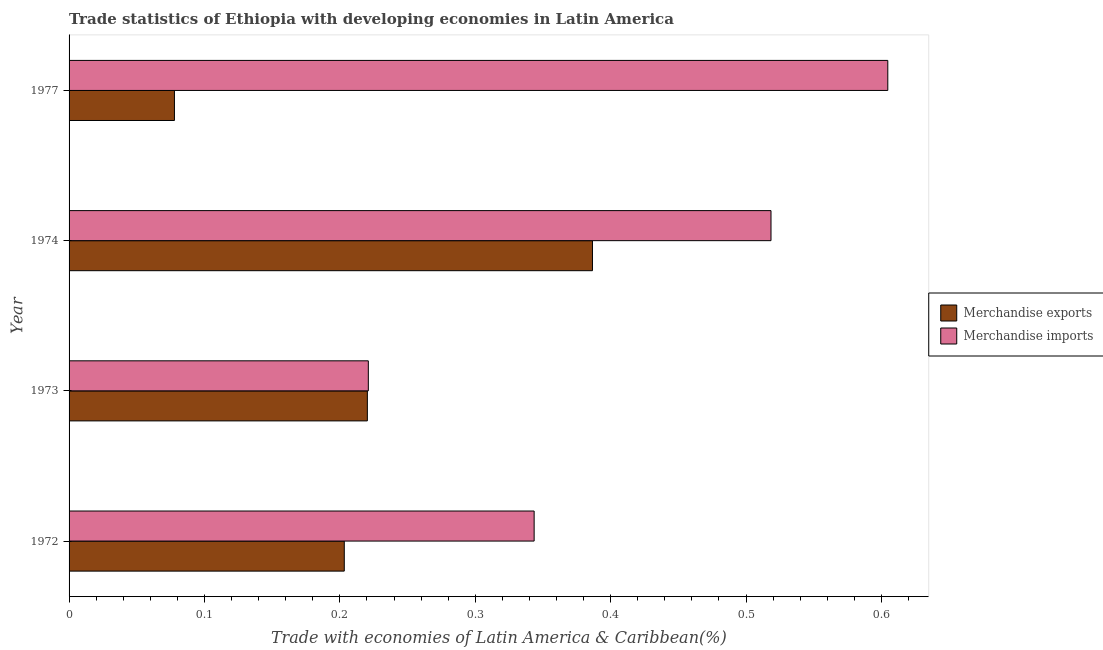Are the number of bars per tick equal to the number of legend labels?
Provide a short and direct response. Yes. Are the number of bars on each tick of the Y-axis equal?
Make the answer very short. Yes. How many bars are there on the 2nd tick from the bottom?
Ensure brevity in your answer.  2. What is the label of the 2nd group of bars from the top?
Give a very brief answer. 1974. What is the merchandise exports in 1973?
Make the answer very short. 0.22. Across all years, what is the maximum merchandise exports?
Provide a succinct answer. 0.39. Across all years, what is the minimum merchandise exports?
Provide a short and direct response. 0.08. In which year was the merchandise exports maximum?
Your answer should be very brief. 1974. In which year was the merchandise exports minimum?
Your answer should be very brief. 1977. What is the total merchandise imports in the graph?
Your answer should be compact. 1.69. What is the difference between the merchandise exports in 1974 and that in 1977?
Give a very brief answer. 0.31. What is the difference between the merchandise exports in 1977 and the merchandise imports in 1972?
Ensure brevity in your answer.  -0.27. What is the average merchandise exports per year?
Make the answer very short. 0.22. In the year 1974, what is the difference between the merchandise imports and merchandise exports?
Keep it short and to the point. 0.13. What is the ratio of the merchandise imports in 1972 to that in 1977?
Give a very brief answer. 0.57. Is the difference between the merchandise imports in 1973 and 1977 greater than the difference between the merchandise exports in 1973 and 1977?
Your answer should be very brief. No. What is the difference between the highest and the second highest merchandise exports?
Offer a very short reply. 0.17. What is the difference between the highest and the lowest merchandise imports?
Give a very brief answer. 0.38. In how many years, is the merchandise exports greater than the average merchandise exports taken over all years?
Your answer should be very brief. 1. How many years are there in the graph?
Ensure brevity in your answer.  4. What is the difference between two consecutive major ticks on the X-axis?
Offer a terse response. 0.1. How are the legend labels stacked?
Keep it short and to the point. Vertical. What is the title of the graph?
Provide a short and direct response. Trade statistics of Ethiopia with developing economies in Latin America. Does "Methane" appear as one of the legend labels in the graph?
Your answer should be compact. No. What is the label or title of the X-axis?
Your answer should be compact. Trade with economies of Latin America & Caribbean(%). What is the Trade with economies of Latin America & Caribbean(%) in Merchandise exports in 1972?
Provide a succinct answer. 0.2. What is the Trade with economies of Latin America & Caribbean(%) of Merchandise imports in 1972?
Offer a terse response. 0.34. What is the Trade with economies of Latin America & Caribbean(%) in Merchandise exports in 1973?
Give a very brief answer. 0.22. What is the Trade with economies of Latin America & Caribbean(%) of Merchandise imports in 1973?
Your answer should be very brief. 0.22. What is the Trade with economies of Latin America & Caribbean(%) of Merchandise exports in 1974?
Ensure brevity in your answer.  0.39. What is the Trade with economies of Latin America & Caribbean(%) of Merchandise imports in 1974?
Offer a very short reply. 0.52. What is the Trade with economies of Latin America & Caribbean(%) of Merchandise exports in 1977?
Your response must be concise. 0.08. What is the Trade with economies of Latin America & Caribbean(%) in Merchandise imports in 1977?
Ensure brevity in your answer.  0.6. Across all years, what is the maximum Trade with economies of Latin America & Caribbean(%) of Merchandise exports?
Provide a short and direct response. 0.39. Across all years, what is the maximum Trade with economies of Latin America & Caribbean(%) in Merchandise imports?
Offer a terse response. 0.6. Across all years, what is the minimum Trade with economies of Latin America & Caribbean(%) of Merchandise exports?
Offer a terse response. 0.08. Across all years, what is the minimum Trade with economies of Latin America & Caribbean(%) of Merchandise imports?
Your answer should be compact. 0.22. What is the total Trade with economies of Latin America & Caribbean(%) of Merchandise exports in the graph?
Give a very brief answer. 0.89. What is the total Trade with economies of Latin America & Caribbean(%) in Merchandise imports in the graph?
Offer a terse response. 1.69. What is the difference between the Trade with economies of Latin America & Caribbean(%) of Merchandise exports in 1972 and that in 1973?
Your answer should be very brief. -0.02. What is the difference between the Trade with economies of Latin America & Caribbean(%) in Merchandise imports in 1972 and that in 1973?
Offer a very short reply. 0.12. What is the difference between the Trade with economies of Latin America & Caribbean(%) in Merchandise exports in 1972 and that in 1974?
Keep it short and to the point. -0.18. What is the difference between the Trade with economies of Latin America & Caribbean(%) in Merchandise imports in 1972 and that in 1974?
Provide a succinct answer. -0.17. What is the difference between the Trade with economies of Latin America & Caribbean(%) in Merchandise exports in 1972 and that in 1977?
Provide a short and direct response. 0.13. What is the difference between the Trade with economies of Latin America & Caribbean(%) in Merchandise imports in 1972 and that in 1977?
Offer a very short reply. -0.26. What is the difference between the Trade with economies of Latin America & Caribbean(%) of Merchandise exports in 1973 and that in 1974?
Offer a terse response. -0.17. What is the difference between the Trade with economies of Latin America & Caribbean(%) of Merchandise imports in 1973 and that in 1974?
Keep it short and to the point. -0.3. What is the difference between the Trade with economies of Latin America & Caribbean(%) in Merchandise exports in 1973 and that in 1977?
Keep it short and to the point. 0.14. What is the difference between the Trade with economies of Latin America & Caribbean(%) of Merchandise imports in 1973 and that in 1977?
Make the answer very short. -0.38. What is the difference between the Trade with economies of Latin America & Caribbean(%) of Merchandise exports in 1974 and that in 1977?
Keep it short and to the point. 0.31. What is the difference between the Trade with economies of Latin America & Caribbean(%) in Merchandise imports in 1974 and that in 1977?
Your answer should be very brief. -0.09. What is the difference between the Trade with economies of Latin America & Caribbean(%) of Merchandise exports in 1972 and the Trade with economies of Latin America & Caribbean(%) of Merchandise imports in 1973?
Make the answer very short. -0.02. What is the difference between the Trade with economies of Latin America & Caribbean(%) of Merchandise exports in 1972 and the Trade with economies of Latin America & Caribbean(%) of Merchandise imports in 1974?
Your answer should be compact. -0.32. What is the difference between the Trade with economies of Latin America & Caribbean(%) of Merchandise exports in 1972 and the Trade with economies of Latin America & Caribbean(%) of Merchandise imports in 1977?
Provide a short and direct response. -0.4. What is the difference between the Trade with economies of Latin America & Caribbean(%) in Merchandise exports in 1973 and the Trade with economies of Latin America & Caribbean(%) in Merchandise imports in 1974?
Provide a short and direct response. -0.3. What is the difference between the Trade with economies of Latin America & Caribbean(%) of Merchandise exports in 1973 and the Trade with economies of Latin America & Caribbean(%) of Merchandise imports in 1977?
Your answer should be very brief. -0.38. What is the difference between the Trade with economies of Latin America & Caribbean(%) of Merchandise exports in 1974 and the Trade with economies of Latin America & Caribbean(%) of Merchandise imports in 1977?
Provide a succinct answer. -0.22. What is the average Trade with economies of Latin America & Caribbean(%) of Merchandise exports per year?
Provide a succinct answer. 0.22. What is the average Trade with economies of Latin America & Caribbean(%) in Merchandise imports per year?
Offer a very short reply. 0.42. In the year 1972, what is the difference between the Trade with economies of Latin America & Caribbean(%) in Merchandise exports and Trade with economies of Latin America & Caribbean(%) in Merchandise imports?
Offer a very short reply. -0.14. In the year 1973, what is the difference between the Trade with economies of Latin America & Caribbean(%) of Merchandise exports and Trade with economies of Latin America & Caribbean(%) of Merchandise imports?
Give a very brief answer. -0. In the year 1974, what is the difference between the Trade with economies of Latin America & Caribbean(%) in Merchandise exports and Trade with economies of Latin America & Caribbean(%) in Merchandise imports?
Provide a succinct answer. -0.13. In the year 1977, what is the difference between the Trade with economies of Latin America & Caribbean(%) of Merchandise exports and Trade with economies of Latin America & Caribbean(%) of Merchandise imports?
Offer a very short reply. -0.53. What is the ratio of the Trade with economies of Latin America & Caribbean(%) of Merchandise exports in 1972 to that in 1973?
Offer a terse response. 0.92. What is the ratio of the Trade with economies of Latin America & Caribbean(%) in Merchandise imports in 1972 to that in 1973?
Give a very brief answer. 1.55. What is the ratio of the Trade with economies of Latin America & Caribbean(%) in Merchandise exports in 1972 to that in 1974?
Offer a very short reply. 0.53. What is the ratio of the Trade with economies of Latin America & Caribbean(%) of Merchandise imports in 1972 to that in 1974?
Your answer should be compact. 0.66. What is the ratio of the Trade with economies of Latin America & Caribbean(%) in Merchandise exports in 1972 to that in 1977?
Offer a terse response. 2.61. What is the ratio of the Trade with economies of Latin America & Caribbean(%) of Merchandise imports in 1972 to that in 1977?
Your answer should be very brief. 0.57. What is the ratio of the Trade with economies of Latin America & Caribbean(%) in Merchandise exports in 1973 to that in 1974?
Provide a succinct answer. 0.57. What is the ratio of the Trade with economies of Latin America & Caribbean(%) of Merchandise imports in 1973 to that in 1974?
Give a very brief answer. 0.43. What is the ratio of the Trade with economies of Latin America & Caribbean(%) in Merchandise exports in 1973 to that in 1977?
Offer a very short reply. 2.83. What is the ratio of the Trade with economies of Latin America & Caribbean(%) in Merchandise imports in 1973 to that in 1977?
Offer a very short reply. 0.37. What is the ratio of the Trade with economies of Latin America & Caribbean(%) in Merchandise exports in 1974 to that in 1977?
Make the answer very short. 4.97. What is the ratio of the Trade with economies of Latin America & Caribbean(%) in Merchandise imports in 1974 to that in 1977?
Your answer should be compact. 0.86. What is the difference between the highest and the second highest Trade with economies of Latin America & Caribbean(%) in Merchandise exports?
Your answer should be very brief. 0.17. What is the difference between the highest and the second highest Trade with economies of Latin America & Caribbean(%) of Merchandise imports?
Give a very brief answer. 0.09. What is the difference between the highest and the lowest Trade with economies of Latin America & Caribbean(%) of Merchandise exports?
Make the answer very short. 0.31. What is the difference between the highest and the lowest Trade with economies of Latin America & Caribbean(%) in Merchandise imports?
Provide a short and direct response. 0.38. 